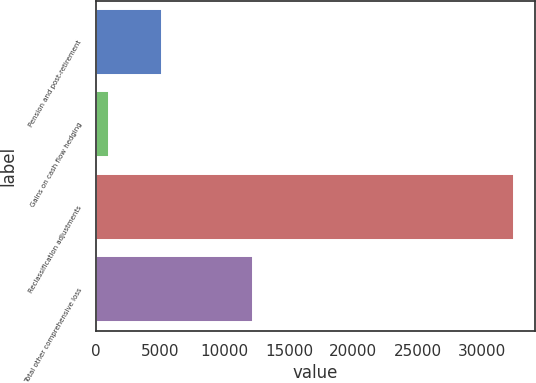<chart> <loc_0><loc_0><loc_500><loc_500><bar_chart><fcel>Pension and post-retirement<fcel>Gains on cash flow hedging<fcel>Reclassification adjustments<fcel>Total other comprehensive loss<nl><fcel>5130<fcel>1001<fcel>32477<fcel>12223<nl></chart> 